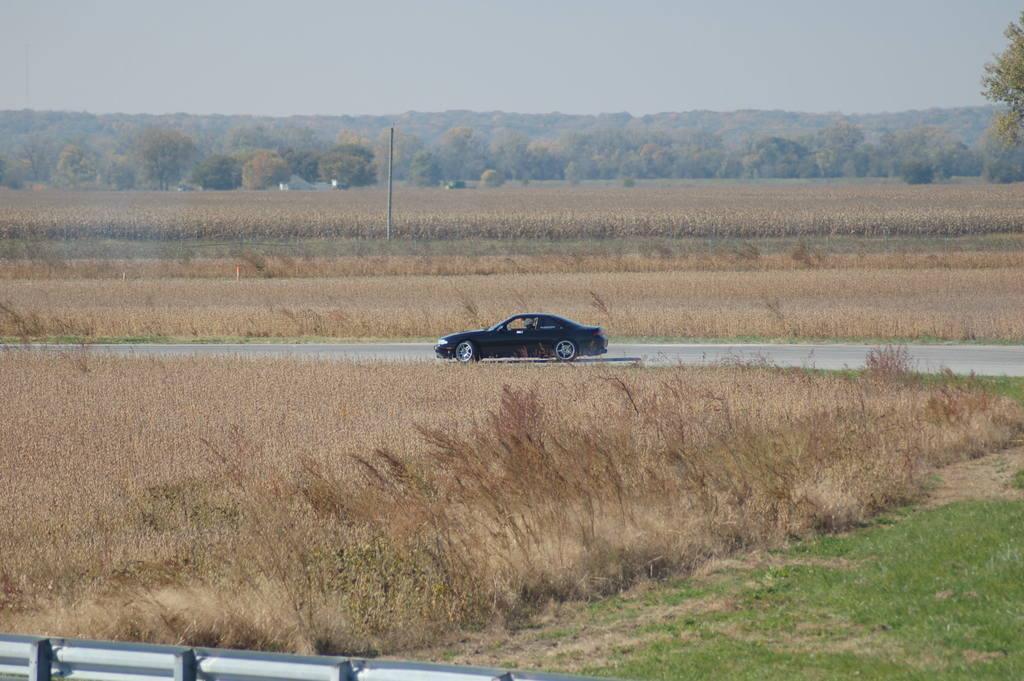Describe this image in one or two sentences. In the center of the image we can see a car is present on the road. In the background of the image we can see the field, some vehicles, poles, trees. At the bottom of the image we can see a barricade and grass. At the top of the image we can see the sky. 